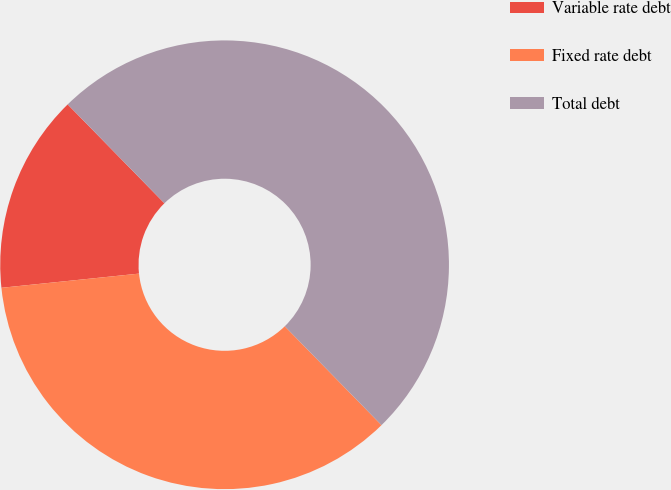<chart> <loc_0><loc_0><loc_500><loc_500><pie_chart><fcel>Variable rate debt<fcel>Fixed rate debt<fcel>Total debt<nl><fcel>14.31%<fcel>35.69%<fcel>50.0%<nl></chart> 